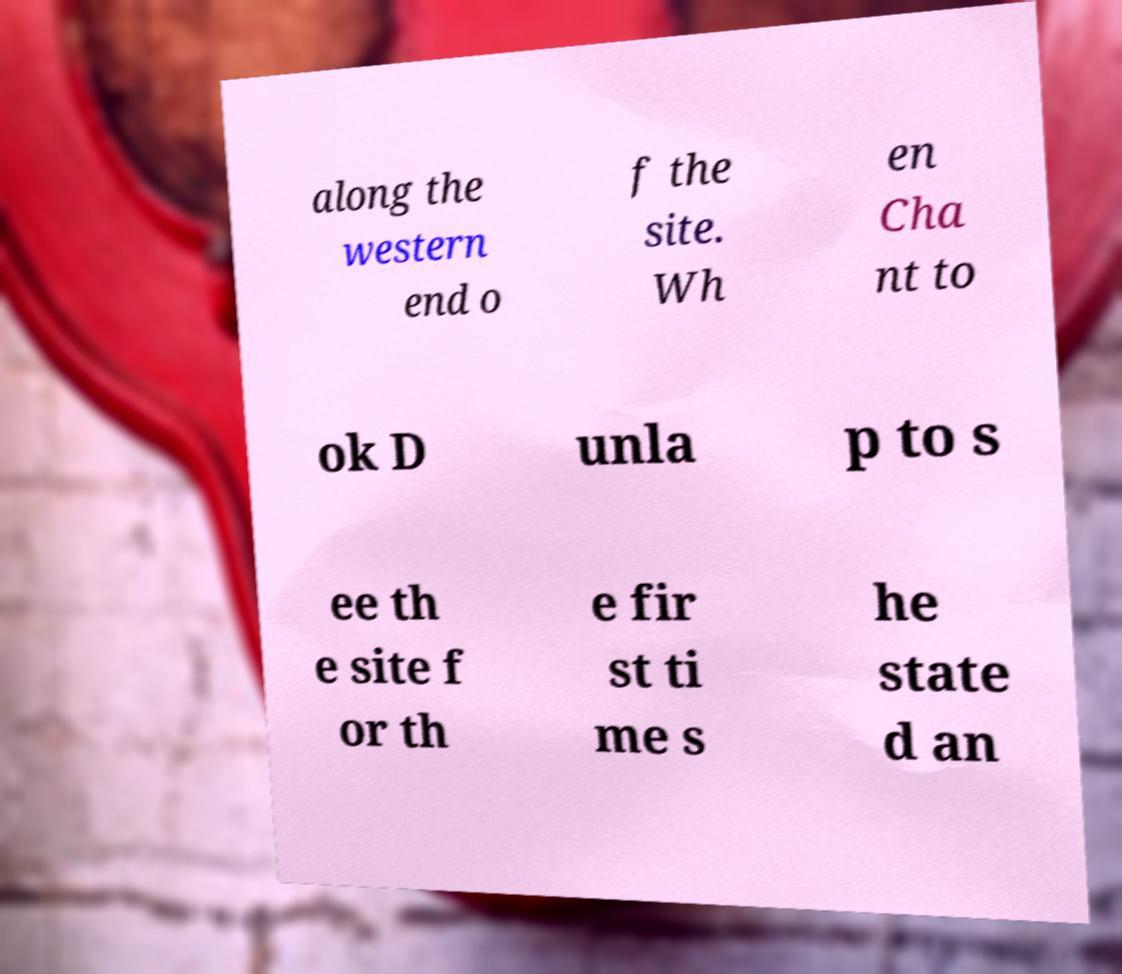Please identify and transcribe the text found in this image. along the western end o f the site. Wh en Cha nt to ok D unla p to s ee th e site f or th e fir st ti me s he state d an 